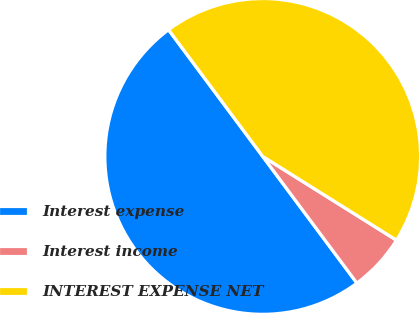Convert chart. <chart><loc_0><loc_0><loc_500><loc_500><pie_chart><fcel>Interest expense<fcel>Interest income<fcel>INTEREST EXPENSE NET<nl><fcel>50.0%<fcel>5.92%<fcel>44.08%<nl></chart> 